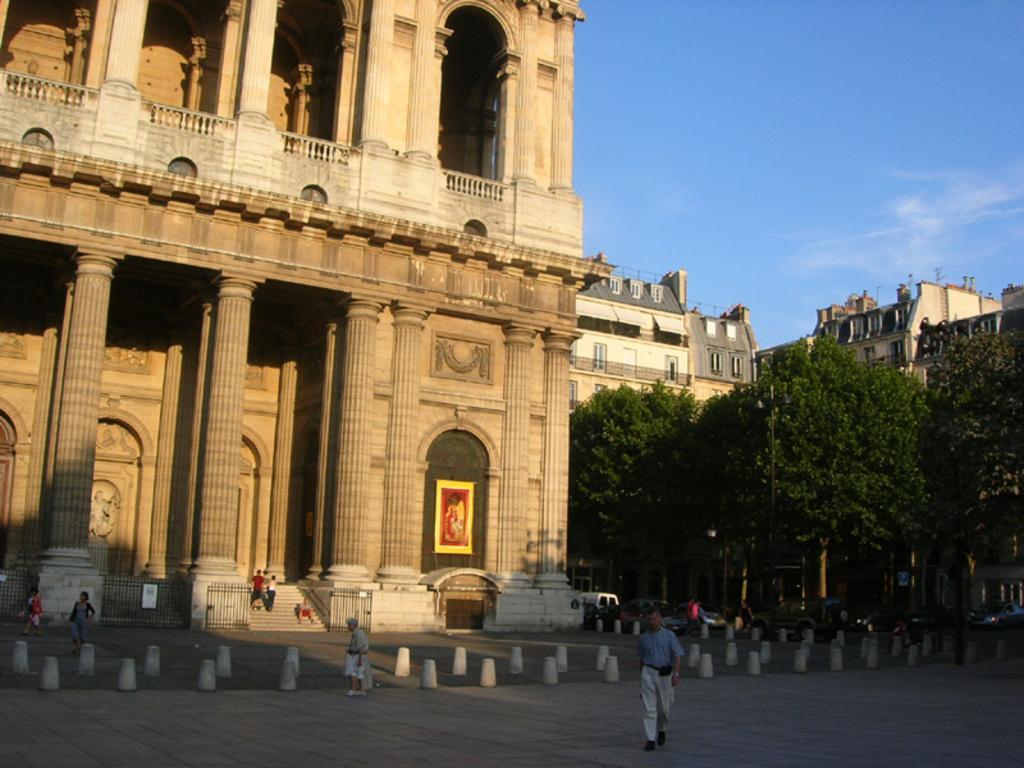Describe this image in one or two sentences. At the bottom of the image few people are standing and walking. Behind them there are some trees and vehicles and buildings. At the top of the image there are some clouds and sky. 